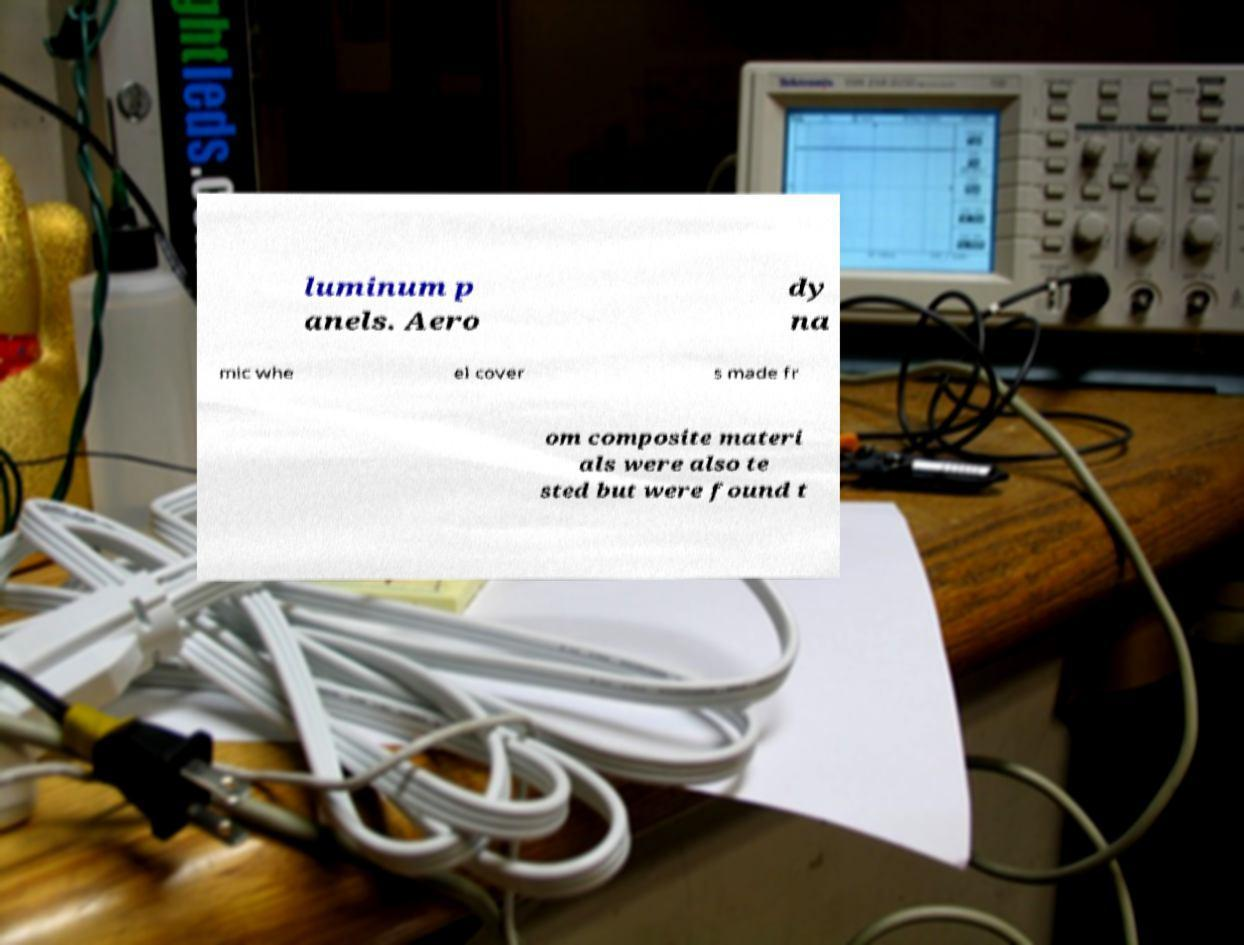There's text embedded in this image that I need extracted. Can you transcribe it verbatim? luminum p anels. Aero dy na mic whe el cover s made fr om composite materi als were also te sted but were found t 